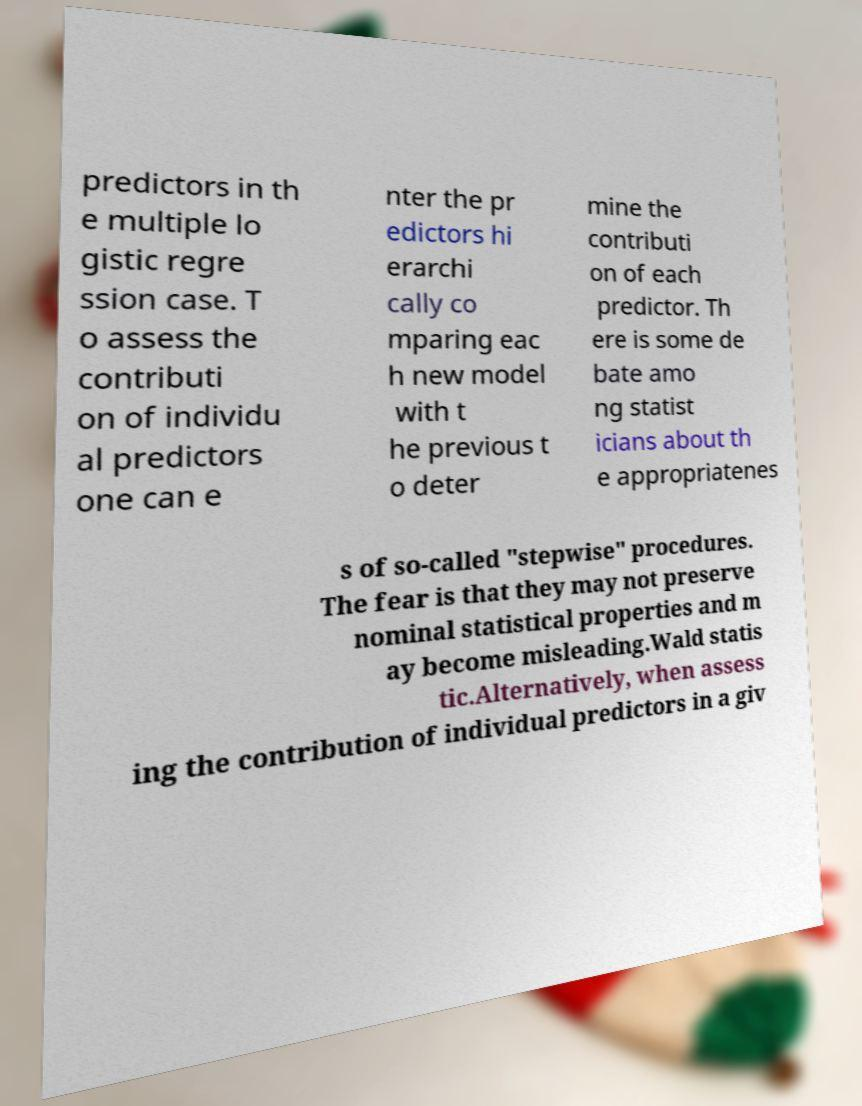Could you extract and type out the text from this image? predictors in th e multiple lo gistic regre ssion case. T o assess the contributi on of individu al predictors one can e nter the pr edictors hi erarchi cally co mparing eac h new model with t he previous t o deter mine the contributi on of each predictor. Th ere is some de bate amo ng statist icians about th e appropriatenes s of so-called "stepwise" procedures. The fear is that they may not preserve nominal statistical properties and m ay become misleading.Wald statis tic.Alternatively, when assess ing the contribution of individual predictors in a giv 